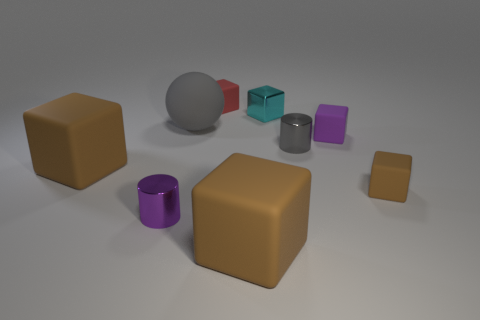How many brown cubes must be subtracted to get 1 brown cubes? 2 Subtract all matte cubes. How many cubes are left? 1 Subtract all yellow cylinders. How many brown blocks are left? 3 Subtract all purple cylinders. How many cylinders are left? 1 Subtract all cylinders. How many objects are left? 7 Subtract all cyan blocks. Subtract all cyan cylinders. How many blocks are left? 5 Subtract all big red metal cylinders. Subtract all small matte things. How many objects are left? 6 Add 5 brown objects. How many brown objects are left? 8 Add 6 yellow things. How many yellow things exist? 6 Subtract 0 green cylinders. How many objects are left? 9 